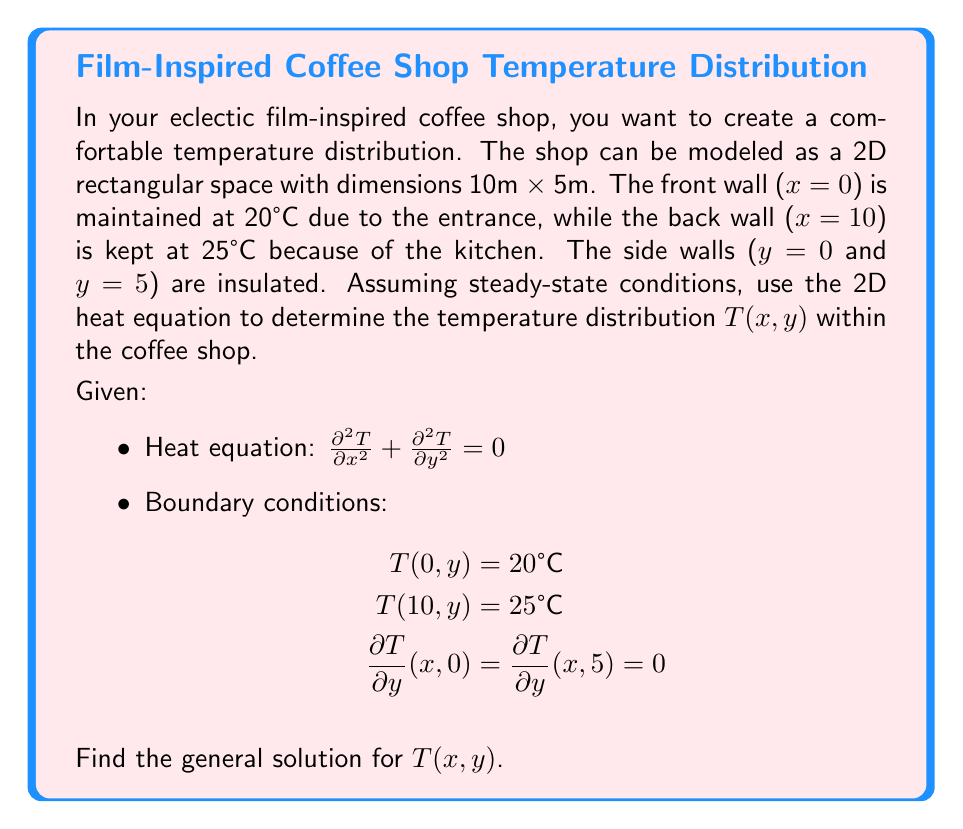What is the answer to this math problem? To solve this problem, we'll use the method of separation of variables.

1) Assume the solution has the form: $T(x,y) = X(x)Y(y)$

2) Substituting into the heat equation:
   $X''(x)Y(y) + X(x)Y''(y) = 0$
   $\frac{X''(x)}{X(x)} = -\frac{Y''(y)}{Y(y)} = -\lambda^2$

3) This gives us two ordinary differential equations:
   $X''(x) + \lambda^2 X(x) = 0$
   $Y''(y) - \lambda^2 Y(y) = 0$

4) The general solutions are:
   $X(x) = A \cos(\lambda x) + B \sin(\lambda x)$
   $Y(y) = C e^{\lambda y} + D e^{-\lambda y}$

5) Applying the boundary conditions for y:
   $Y'(0) = Y'(5) = 0$ implies $C = D$ and $\lambda = \frac{n\pi}{5}$, where n is an integer.

6) Therefore, $Y_n(y) = C_n \cosh(\frac{n\pi y}{5})$

7) The general solution is now:
   $T(x,y) = \sum_{n=0}^{\infty} (A_n \cos(\frac{n\pi x}{5}) + B_n \sin(\frac{n\pi x}{5})) \cosh(\frac{n\pi y}{5})$

8) Applying the boundary conditions for x:
   T(0,y) = 20 implies $\sum_{n=0}^{\infty} A_n \cosh(\frac{n\pi y}{5}) = 20$
   T(10,y) = 25 implies $\sum_{n=0}^{\infty} (A_n \cos(2n\pi) + B_n \sin(2n\pi)) \cosh(\frac{n\pi y}{5}) = 25$

9) These conditions are satisfied by:
   $A_0 = 22.5$
   $A_n = 0$ for $n \geq 1$
   $B_n = \frac{5}{n\pi} \sin(\frac{n\pi}{2})$ for odd n, 0 for even n

10) Therefore, the final solution is:
    $T(x,y) = 22.5 + \sum_{n=1,3,5,...}^{\infty} \frac{5}{n\pi} \sin(\frac{n\pi}{2}) \sin(\frac{n\pi x}{5}) \cosh(\frac{n\pi y}{5})$
Answer: $T(x,y) = 22.5 + \sum_{n=1,3,5,...}^{\infty} \frac{5}{n\pi} \sin(\frac{n\pi}{2}) \sin(\frac{n\pi x}{5}) \cosh(\frac{n\pi y}{5})$ 